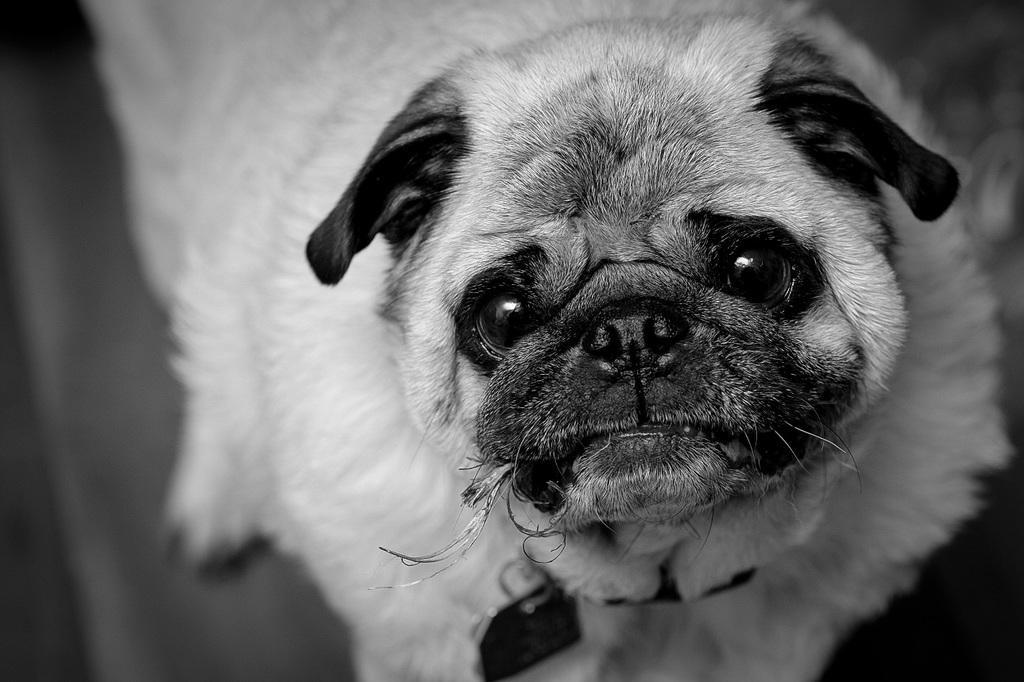Can you describe this image briefly? In this image we can see the black and white image and we can see a dog. 